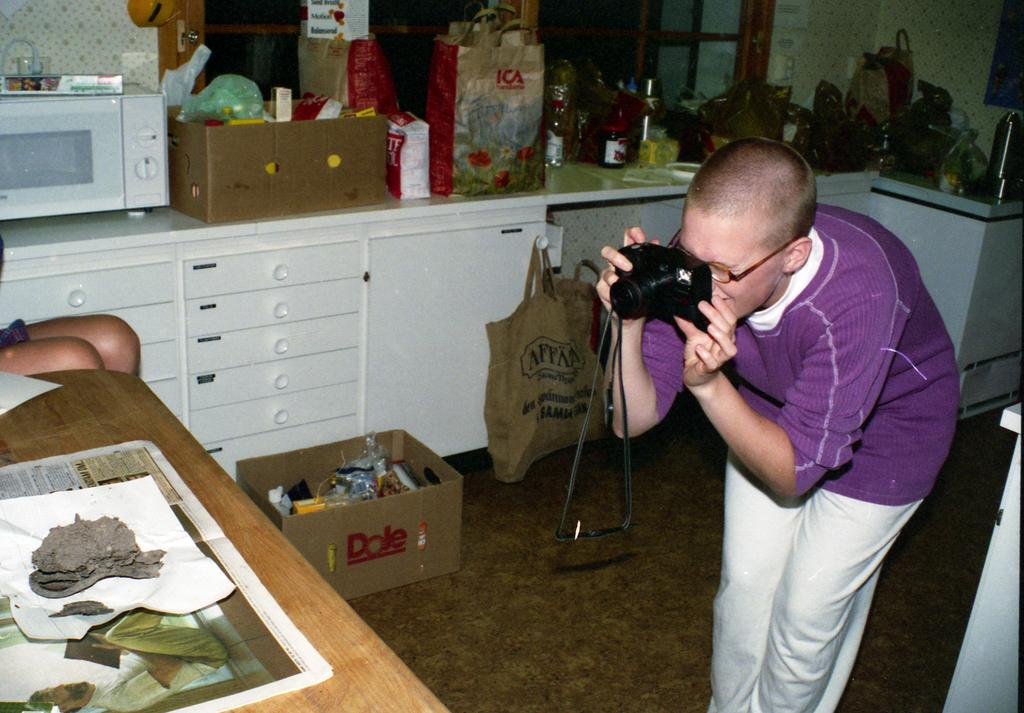What is the man in the image doing? The man is standing in the image and holding a camera in his hands. What objects can be seen on the table in the image? There are papers on a table in the image. What appliance is visible in the image? There is a microwave oven visible in the image. What item is on the counter top of the kitchen in the image? There is a bag on the counter top of the kitchen in the image. What type of pen is being used to test the limits of the microwave oven in the image? There is no pen or testing of limits visible in the image; it only shows a man holding a camera, papers on a table, a microwave oven, and a bag on the counter top. 